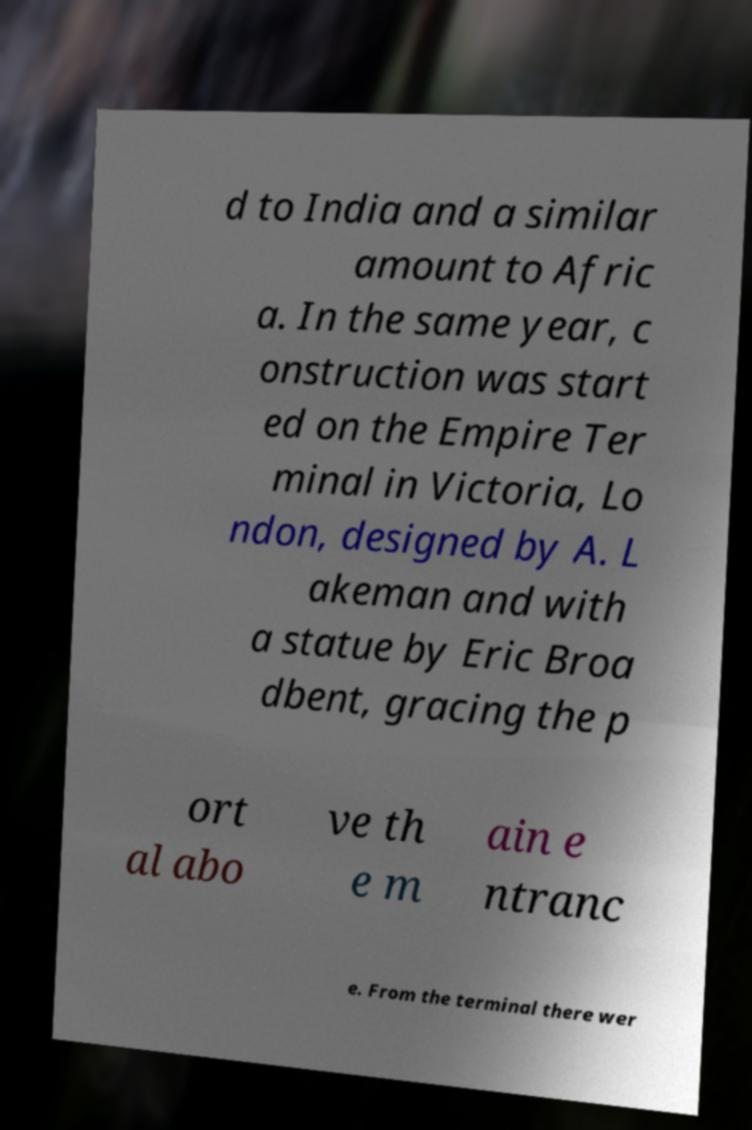Could you assist in decoding the text presented in this image and type it out clearly? d to India and a similar amount to Afric a. In the same year, c onstruction was start ed on the Empire Ter minal in Victoria, Lo ndon, designed by A. L akeman and with a statue by Eric Broa dbent, gracing the p ort al abo ve th e m ain e ntranc e. From the terminal there wer 